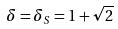Convert formula to latex. <formula><loc_0><loc_0><loc_500><loc_500>\delta = \delta _ { S } = 1 + \sqrt { 2 }</formula> 